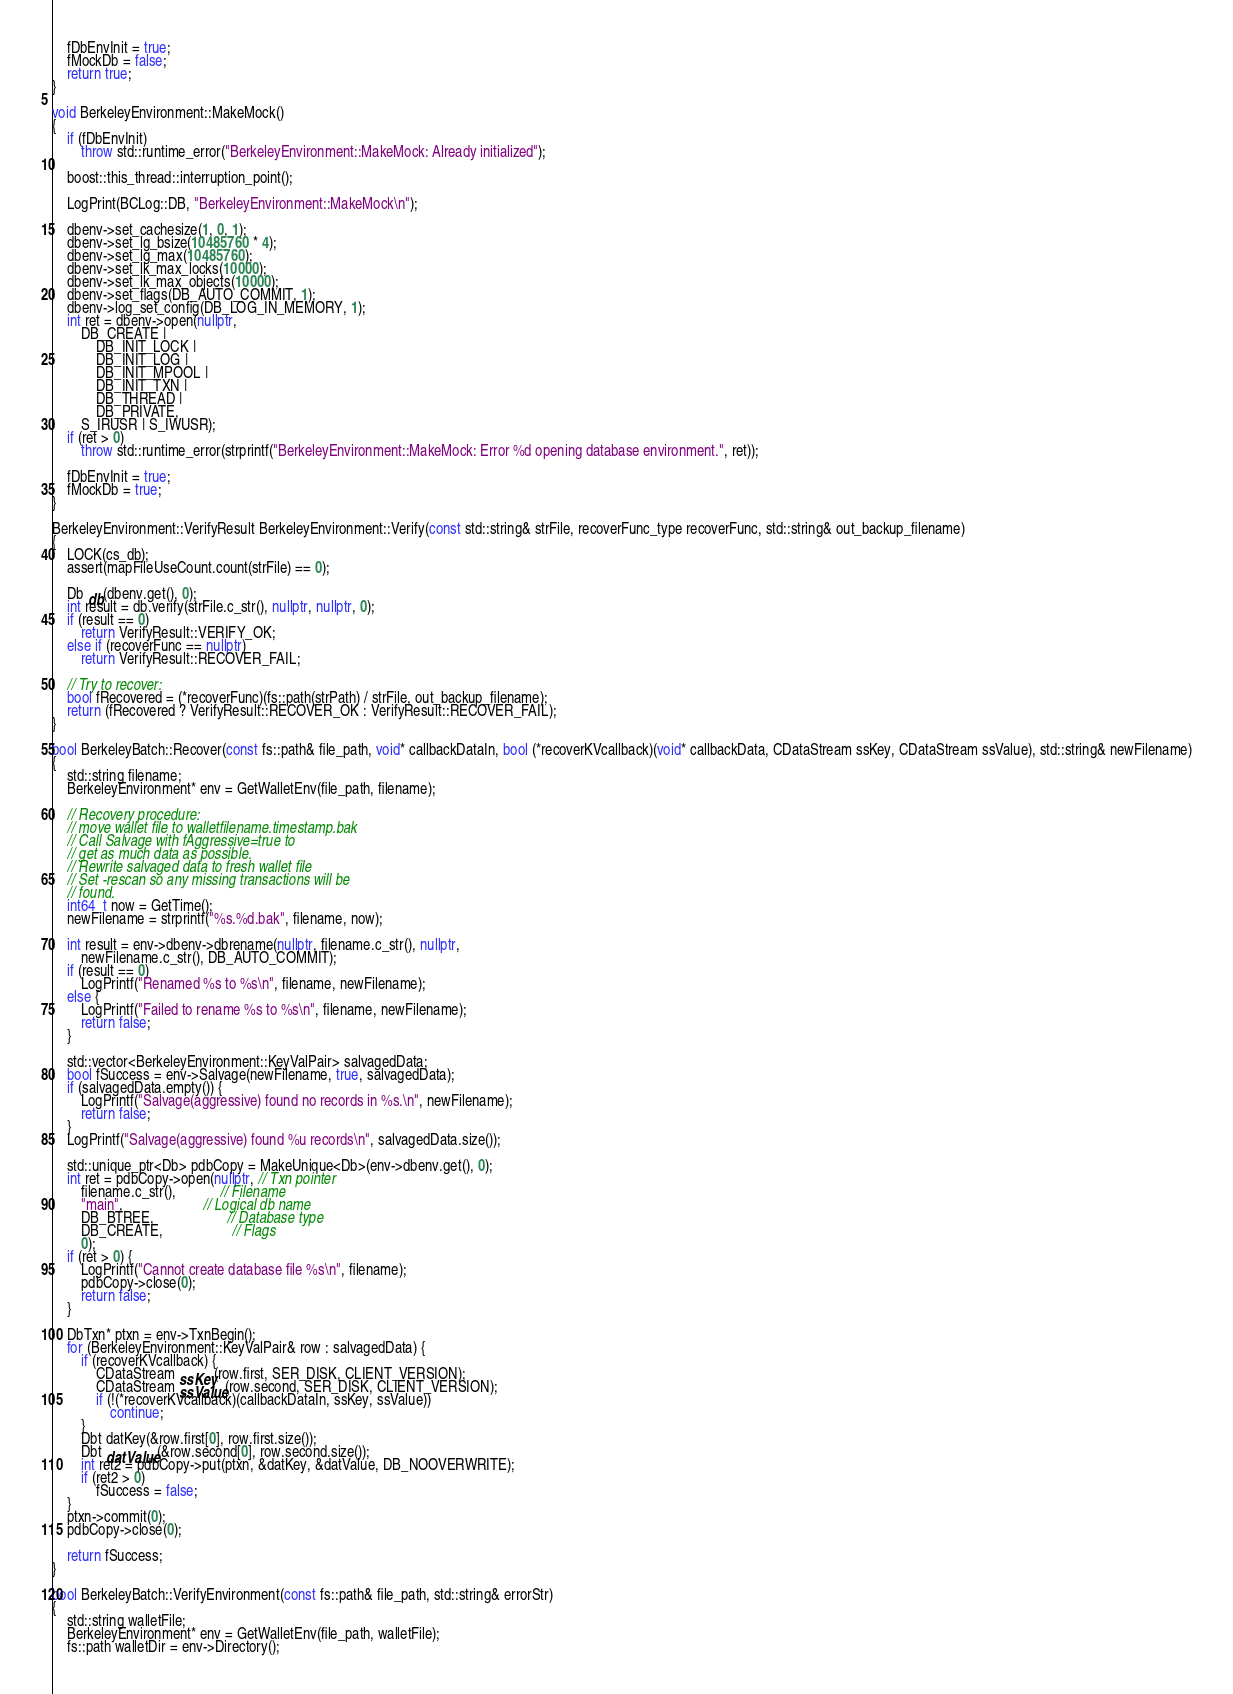Convert code to text. <code><loc_0><loc_0><loc_500><loc_500><_C++_>
    fDbEnvInit = true;
    fMockDb = false;
    return true;
}

void BerkeleyEnvironment::MakeMock()
{
    if (fDbEnvInit)
        throw std::runtime_error("BerkeleyEnvironment::MakeMock: Already initialized");

    boost::this_thread::interruption_point();

    LogPrint(BCLog::DB, "BerkeleyEnvironment::MakeMock\n");

    dbenv->set_cachesize(1, 0, 1);
    dbenv->set_lg_bsize(10485760 * 4);
    dbenv->set_lg_max(10485760);
    dbenv->set_lk_max_locks(10000);
    dbenv->set_lk_max_objects(10000);
    dbenv->set_flags(DB_AUTO_COMMIT, 1);
    dbenv->log_set_config(DB_LOG_IN_MEMORY, 1);
    int ret = dbenv->open(nullptr,
        DB_CREATE |
            DB_INIT_LOCK |
            DB_INIT_LOG |
            DB_INIT_MPOOL |
            DB_INIT_TXN |
            DB_THREAD |
            DB_PRIVATE,
        S_IRUSR | S_IWUSR);
    if (ret > 0)
        throw std::runtime_error(strprintf("BerkeleyEnvironment::MakeMock: Error %d opening database environment.", ret));

    fDbEnvInit = true;
    fMockDb = true;
}

BerkeleyEnvironment::VerifyResult BerkeleyEnvironment::Verify(const std::string& strFile, recoverFunc_type recoverFunc, std::string& out_backup_filename)
{
    LOCK(cs_db);
    assert(mapFileUseCount.count(strFile) == 0);

    Db db(dbenv.get(), 0);
    int result = db.verify(strFile.c_str(), nullptr, nullptr, 0);
    if (result == 0)
        return VerifyResult::VERIFY_OK;
    else if (recoverFunc == nullptr)
        return VerifyResult::RECOVER_FAIL;

    // Try to recover:
    bool fRecovered = (*recoverFunc)(fs::path(strPath) / strFile, out_backup_filename);
    return (fRecovered ? VerifyResult::RECOVER_OK : VerifyResult::RECOVER_FAIL);
}

bool BerkeleyBatch::Recover(const fs::path& file_path, void* callbackDataIn, bool (*recoverKVcallback)(void* callbackData, CDataStream ssKey, CDataStream ssValue), std::string& newFilename)
{
    std::string filename;
    BerkeleyEnvironment* env = GetWalletEnv(file_path, filename);

    // Recovery procedure:
    // move wallet file to walletfilename.timestamp.bak
    // Call Salvage with fAggressive=true to
    // get as much data as possible.
    // Rewrite salvaged data to fresh wallet file
    // Set -rescan so any missing transactions will be
    // found.
    int64_t now = GetTime();
    newFilename = strprintf("%s.%d.bak", filename, now);

    int result = env->dbenv->dbrename(nullptr, filename.c_str(), nullptr,
        newFilename.c_str(), DB_AUTO_COMMIT);
    if (result == 0)
        LogPrintf("Renamed %s to %s\n", filename, newFilename);
    else {
        LogPrintf("Failed to rename %s to %s\n", filename, newFilename);
        return false;
    }

    std::vector<BerkeleyEnvironment::KeyValPair> salvagedData;
    bool fSuccess = env->Salvage(newFilename, true, salvagedData);
    if (salvagedData.empty()) {
        LogPrintf("Salvage(aggressive) found no records in %s.\n", newFilename);
        return false;
    }
    LogPrintf("Salvage(aggressive) found %u records\n", salvagedData.size());

    std::unique_ptr<Db> pdbCopy = MakeUnique<Db>(env->dbenv.get(), 0);
    int ret = pdbCopy->open(nullptr, // Txn pointer
        filename.c_str(),            // Filename
        "main",                      // Logical db name
        DB_BTREE,                    // Database type
        DB_CREATE,                   // Flags
        0);
    if (ret > 0) {
        LogPrintf("Cannot create database file %s\n", filename);
        pdbCopy->close(0);
        return false;
    }

    DbTxn* ptxn = env->TxnBegin();
    for (BerkeleyEnvironment::KeyValPair& row : salvagedData) {
        if (recoverKVcallback) {
            CDataStream ssKey(row.first, SER_DISK, CLIENT_VERSION);
            CDataStream ssValue(row.second, SER_DISK, CLIENT_VERSION);
            if (!(*recoverKVcallback)(callbackDataIn, ssKey, ssValue))
                continue;
        }
        Dbt datKey(&row.first[0], row.first.size());
        Dbt datValue(&row.second[0], row.second.size());
        int ret2 = pdbCopy->put(ptxn, &datKey, &datValue, DB_NOOVERWRITE);
        if (ret2 > 0)
            fSuccess = false;
    }
    ptxn->commit(0);
    pdbCopy->close(0);

    return fSuccess;
}

bool BerkeleyBatch::VerifyEnvironment(const fs::path& file_path, std::string& errorStr)
{
    std::string walletFile;
    BerkeleyEnvironment* env = GetWalletEnv(file_path, walletFile);
    fs::path walletDir = env->Directory();
</code> 